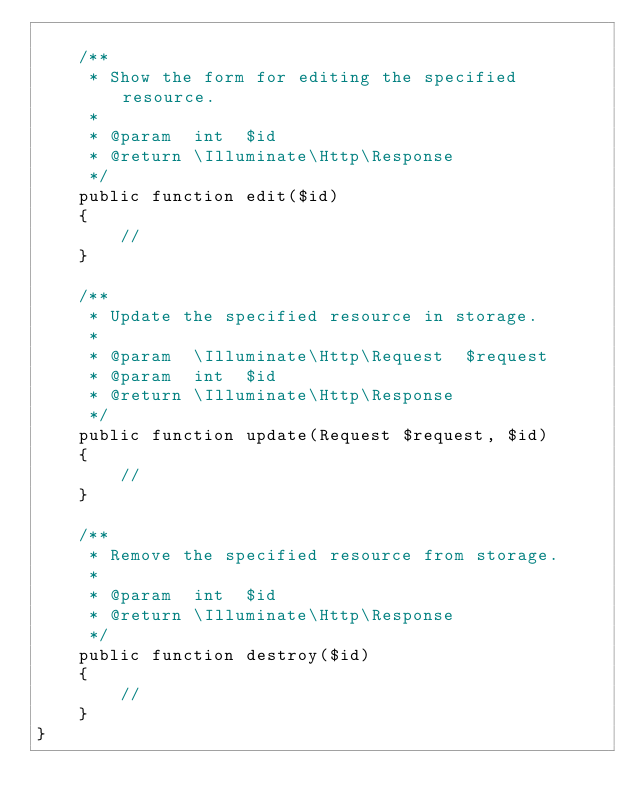Convert code to text. <code><loc_0><loc_0><loc_500><loc_500><_PHP_>
    /**
     * Show the form for editing the specified resource.
     *
     * @param  int  $id
     * @return \Illuminate\Http\Response
     */
    public function edit($id)
    {
        //
    }

    /**
     * Update the specified resource in storage.
     *
     * @param  \Illuminate\Http\Request  $request
     * @param  int  $id
     * @return \Illuminate\Http\Response
     */
    public function update(Request $request, $id)
    {
        //
    }

    /**
     * Remove the specified resource from storage.
     *
     * @param  int  $id
     * @return \Illuminate\Http\Response
     */
    public function destroy($id)
    {
        //
    }
}
</code> 